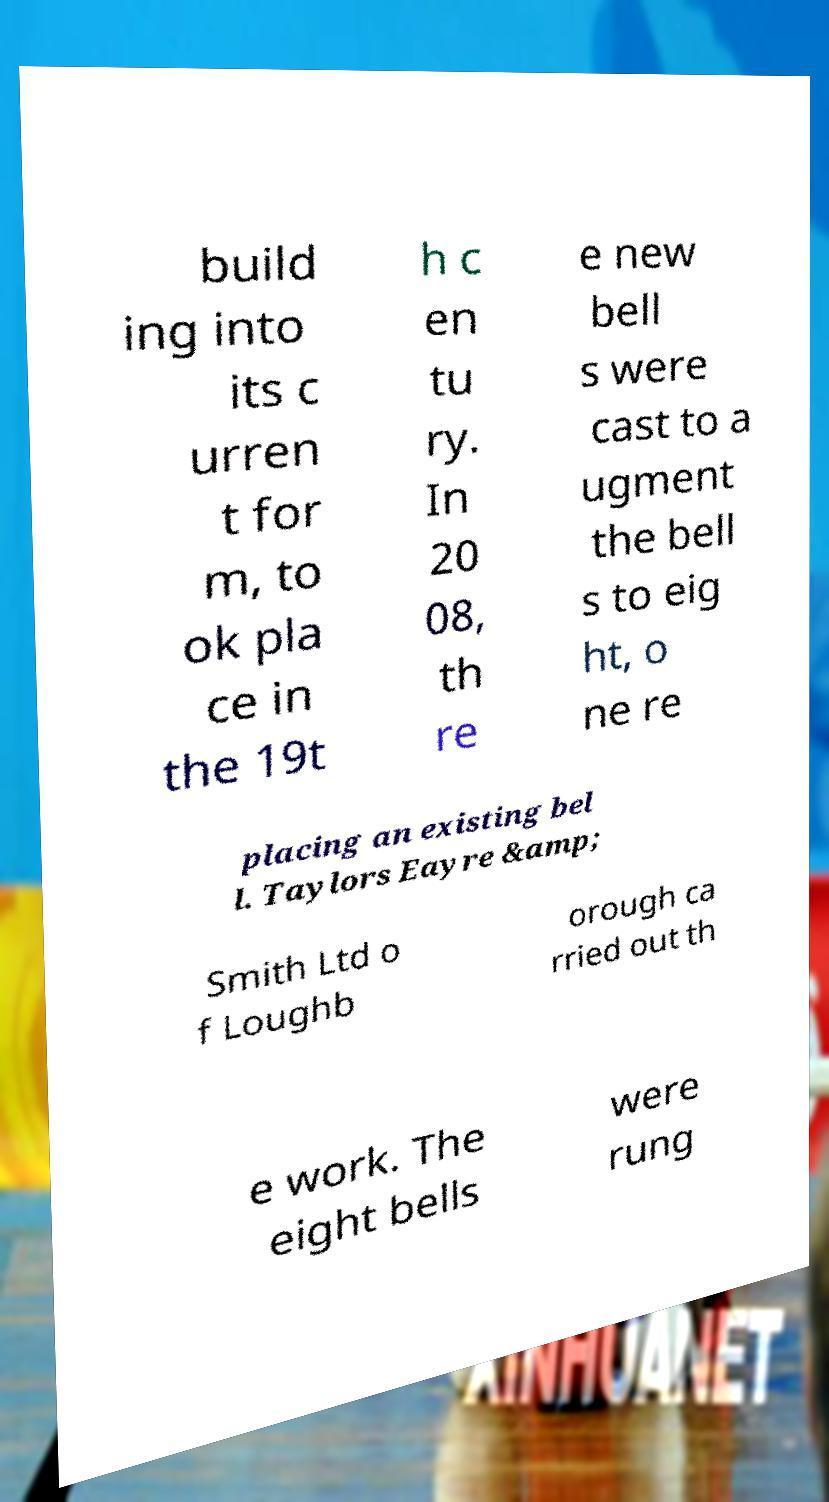Please read and relay the text visible in this image. What does it say? build ing into its c urren t for m, to ok pla ce in the 19t h c en tu ry. In 20 08, th re e new bell s were cast to a ugment the bell s to eig ht, o ne re placing an existing bel l. Taylors Eayre &amp; Smith Ltd o f Loughb orough ca rried out th e work. The eight bells were rung 